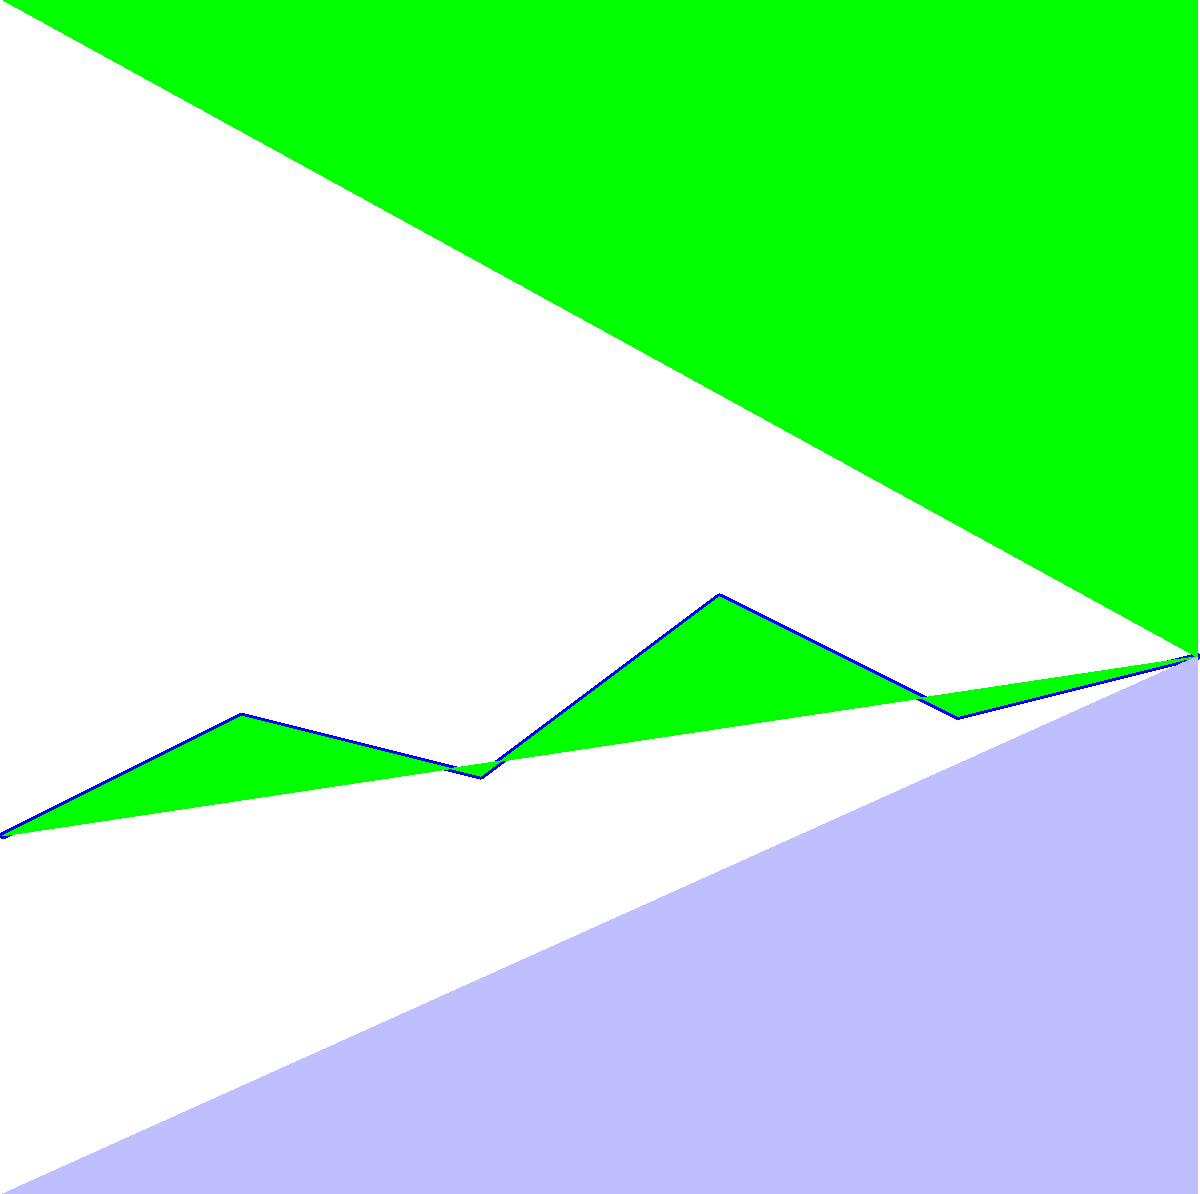As a lobster fisherman relying on maritime communication, you notice that your radio signal weakens as you sail further from the coast. Based on the coverage map, what is the maximum distance from the radio tower where you can still maintain reliable communication, assuming you need to be within the second coverage ring? To answer this question, we need to analyze the radio wave propagation pattern shown in the coverage map. Let's break it down step-by-step:

1. The map shows a coastline with land and sea areas clearly marked.
2. There's a radio tower located at the center of the map, presumably on the coast.
3. The radio wave coverage is represented by three concentric dashed circles around the tower.
4. These circles represent different coverage radii, as indicated in the key:
   - The innermost circle has a radius of 2 km
   - The middle circle has a radius of 4 km
   - The outermost circle has a radius of 6 km

5. The question asks for the maximum distance for reliable communication within the second coverage ring.
6. The second coverage ring corresponds to the middle circle.
7. According to the key, the middle circle represents a coverage radius of 4 km.

Therefore, the maximum distance from the radio tower where you can still maintain reliable communication, assuming you need to be within the second coverage ring, is 4 km.

This distance takes into account the challenges of maritime communication, where factors such as sea conditions, atmospheric effects, and the curvature of the Earth can impact radio wave propagation. As a lobster fisherman, staying within this 4 km radius ensures that you can maintain contact with the shore and other vessels, which is crucial for safety and coordination of fishing activities.
Answer: 4 km 